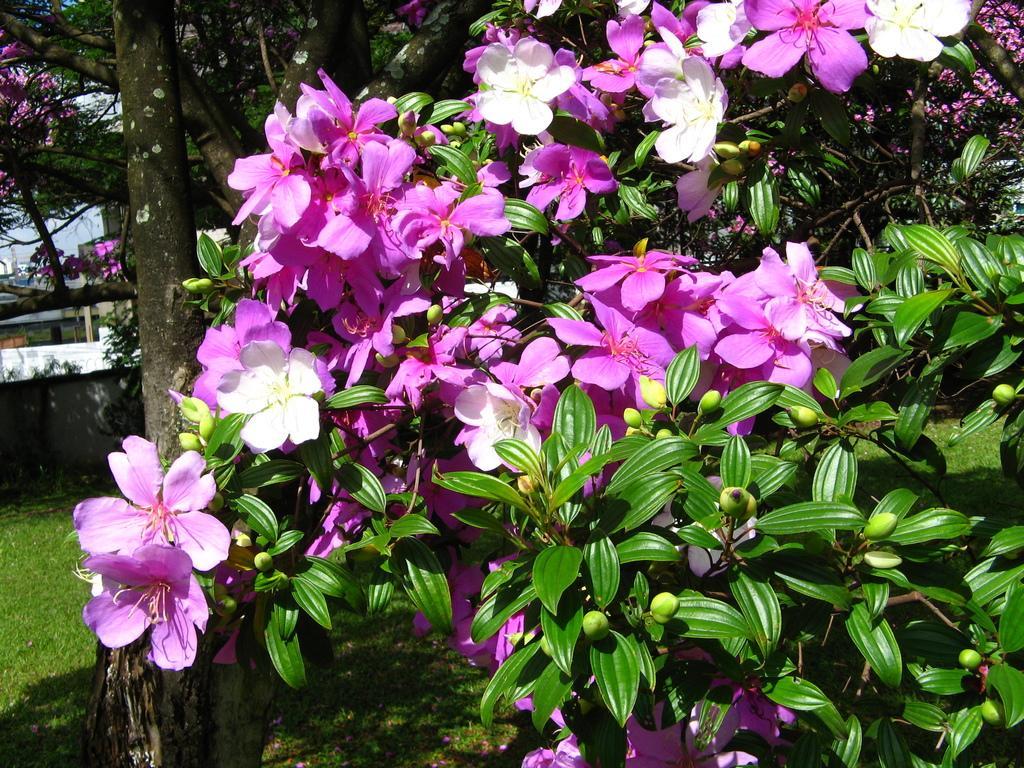Please provide a concise description of this image. In this image, we can see some plants, flowers, trees. We can see the ground with some grass. We can also see the sky and some objects on the left. 